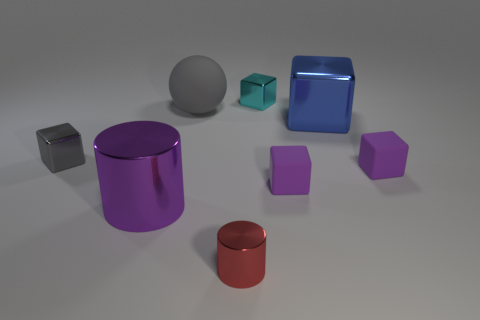Subtract all big blue cubes. How many cubes are left? 4 Subtract all red cylinders. How many purple blocks are left? 2 Add 1 metal cylinders. How many objects exist? 9 Subtract 2 blocks. How many blocks are left? 3 Subtract all purple blocks. How many blocks are left? 3 Subtract all cylinders. How many objects are left? 6 Subtract all blue cubes. Subtract all red cylinders. How many cubes are left? 4 Subtract all big blue matte cylinders. Subtract all gray things. How many objects are left? 6 Add 7 small gray cubes. How many small gray cubes are left? 8 Add 6 cyan blocks. How many cyan blocks exist? 7 